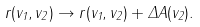Convert formula to latex. <formula><loc_0><loc_0><loc_500><loc_500>r ( v _ { 1 } , v _ { 2 } ) \to r ( v _ { 1 } , v _ { 2 } ) + \Delta A ( v _ { 2 } ) .</formula> 